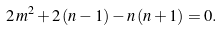<formula> <loc_0><loc_0><loc_500><loc_500>2 \, m ^ { 2 } + 2 \, ( n - 1 ) - n \, ( n + 1 ) = 0 .</formula> 